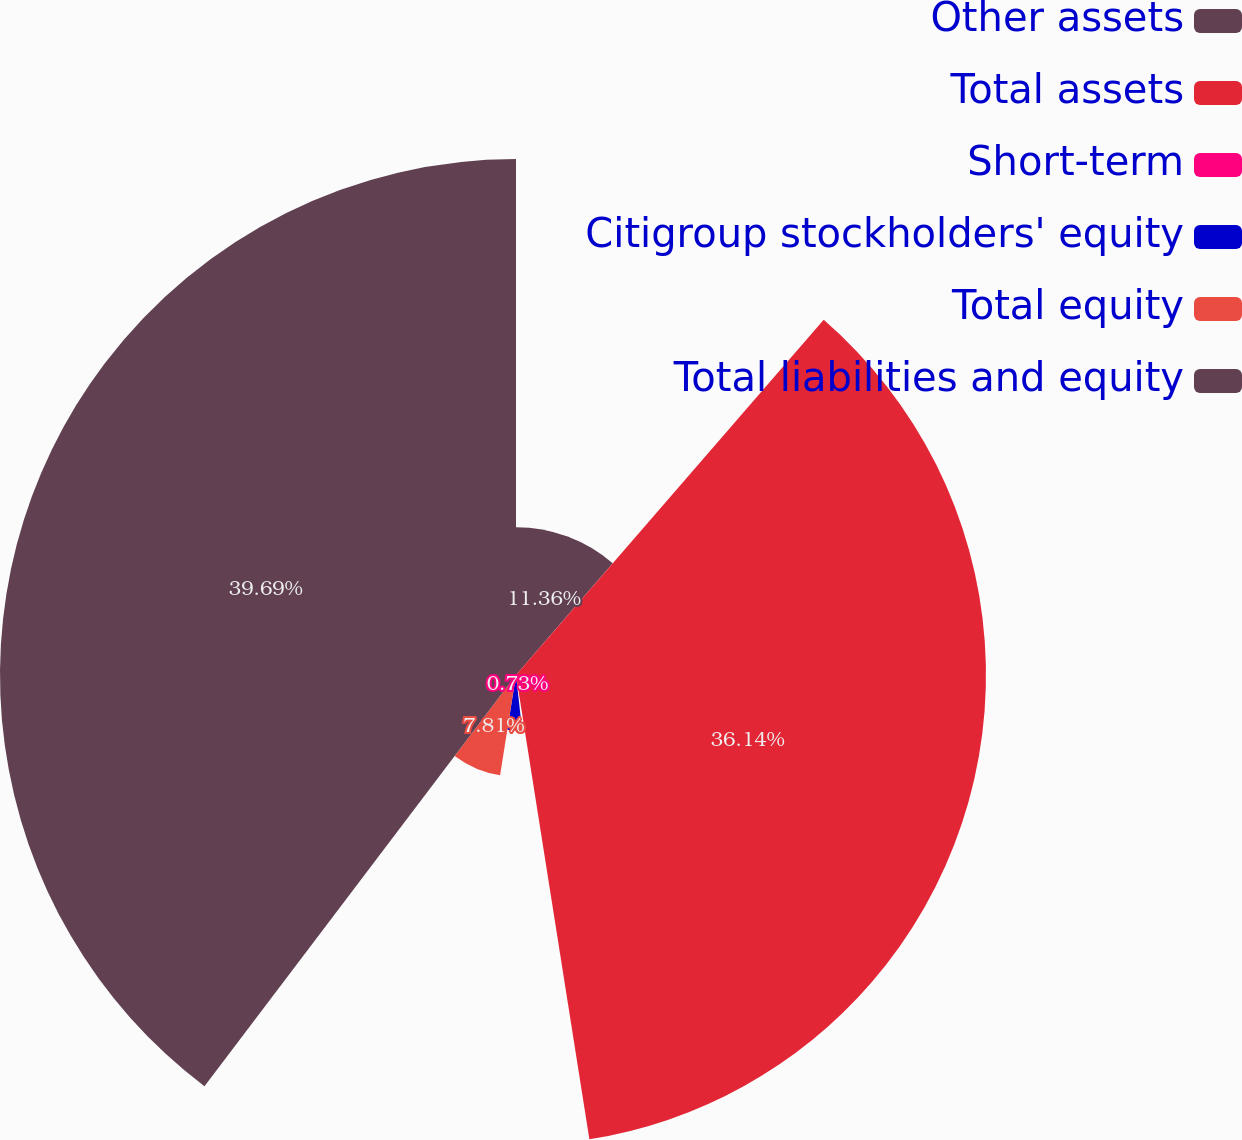Convert chart to OTSL. <chart><loc_0><loc_0><loc_500><loc_500><pie_chart><fcel>Other assets<fcel>Total assets<fcel>Short-term<fcel>Citigroup stockholders' equity<fcel>Total equity<fcel>Total liabilities and equity<nl><fcel>11.36%<fcel>36.14%<fcel>0.73%<fcel>4.27%<fcel>7.81%<fcel>39.68%<nl></chart> 